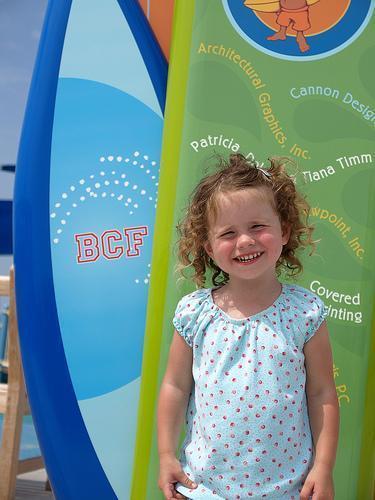How many girls are there?
Give a very brief answer. 1. 